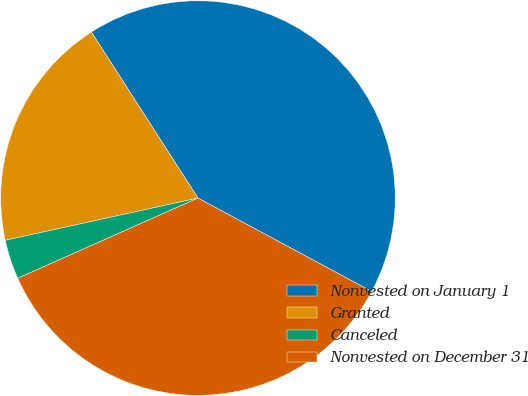<chart> <loc_0><loc_0><loc_500><loc_500><pie_chart><fcel>Nonvested on January 1<fcel>Granted<fcel>Canceled<fcel>Nonvested on December 31<nl><fcel>41.94%<fcel>19.35%<fcel>3.23%<fcel>35.48%<nl></chart> 